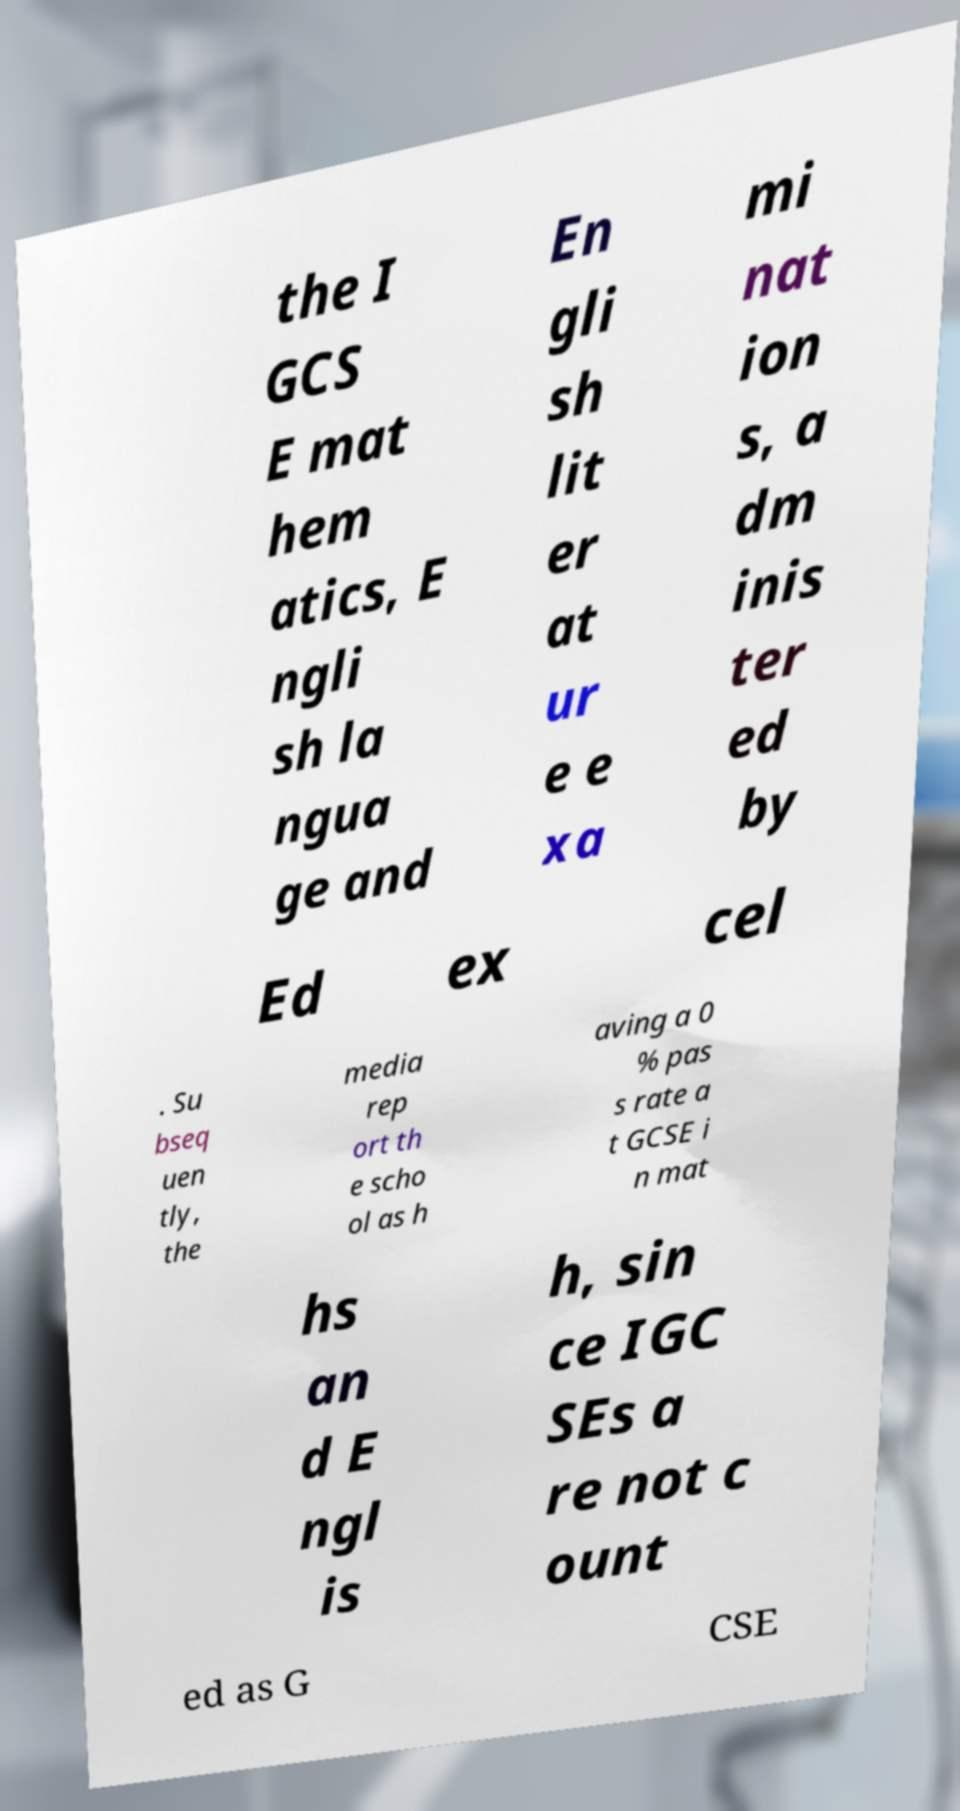Can you read and provide the text displayed in the image?This photo seems to have some interesting text. Can you extract and type it out for me? the I GCS E mat hem atics, E ngli sh la ngua ge and En gli sh lit er at ur e e xa mi nat ion s, a dm inis ter ed by Ed ex cel . Su bseq uen tly, the media rep ort th e scho ol as h aving a 0 % pas s rate a t GCSE i n mat hs an d E ngl is h, sin ce IGC SEs a re not c ount ed as G CSE 